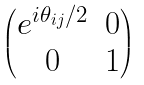<formula> <loc_0><loc_0><loc_500><loc_500>\begin{pmatrix} e ^ { i \theta _ { i j } / 2 } & 0 \\ 0 & 1 \end{pmatrix}</formula> 